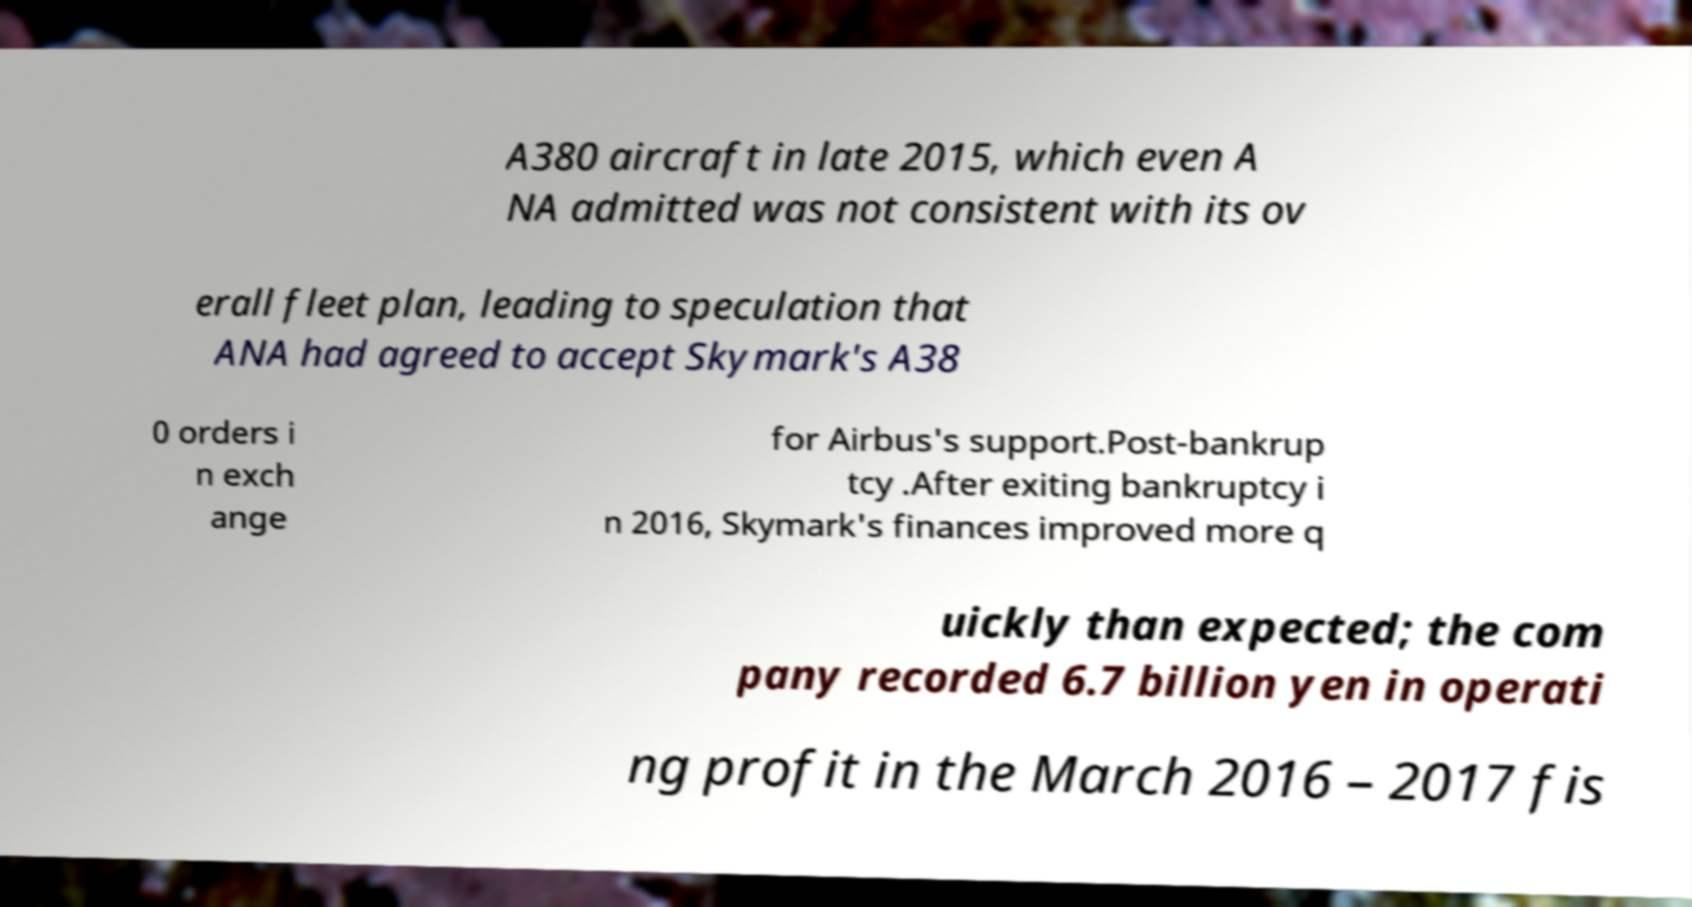For documentation purposes, I need the text within this image transcribed. Could you provide that? A380 aircraft in late 2015, which even A NA admitted was not consistent with its ov erall fleet plan, leading to speculation that ANA had agreed to accept Skymark's A38 0 orders i n exch ange for Airbus's support.Post-bankrup tcy .After exiting bankruptcy i n 2016, Skymark's finances improved more q uickly than expected; the com pany recorded 6.7 billion yen in operati ng profit in the March 2016 – 2017 fis 